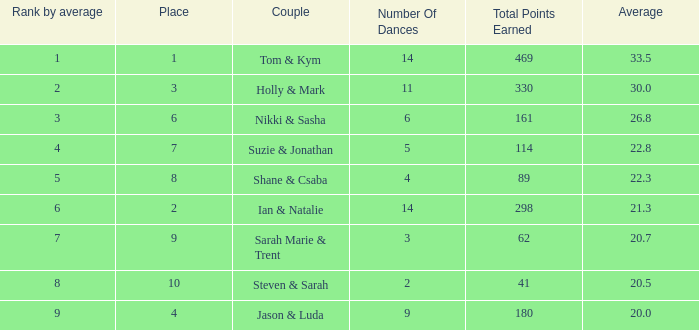What is the name of the twosome if the cumulative points achieved is 161? Nikki & Sasha. 